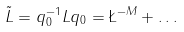<formula> <loc_0><loc_0><loc_500><loc_500>\tilde { L } = q _ { 0 } ^ { - 1 } L q _ { 0 } = \L ^ { - M } + \dots</formula> 